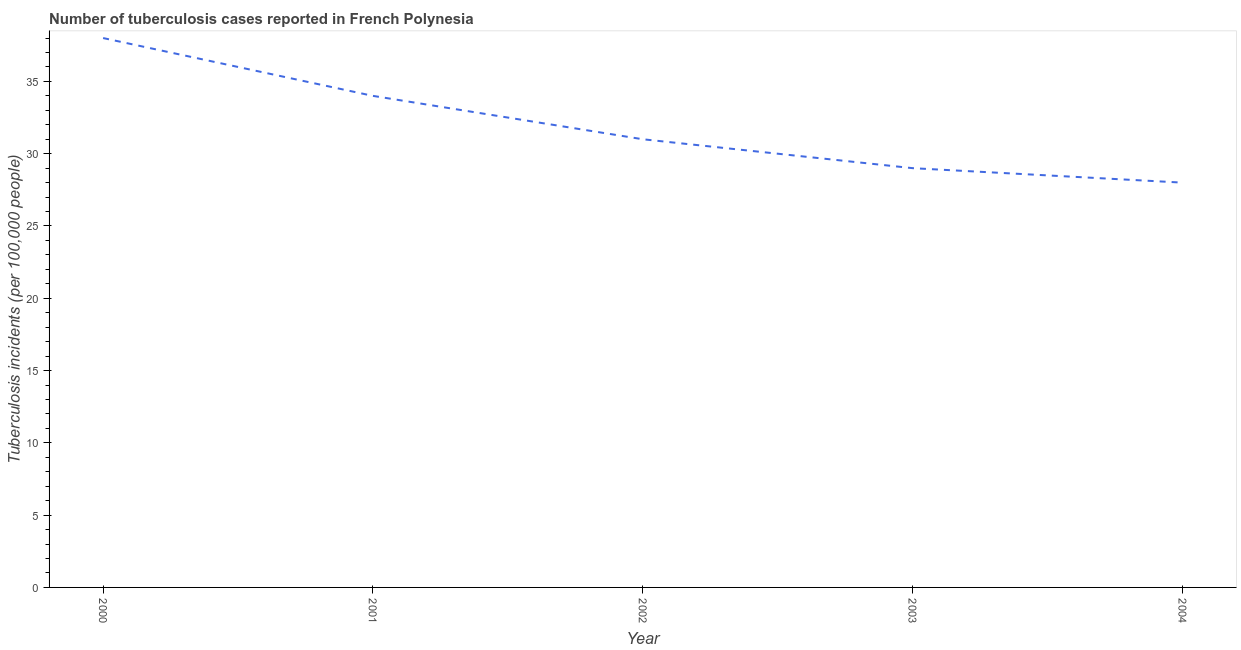What is the number of tuberculosis incidents in 2003?
Offer a very short reply. 29. Across all years, what is the maximum number of tuberculosis incidents?
Your response must be concise. 38. Across all years, what is the minimum number of tuberculosis incidents?
Keep it short and to the point. 28. In which year was the number of tuberculosis incidents maximum?
Your answer should be compact. 2000. In which year was the number of tuberculosis incidents minimum?
Provide a short and direct response. 2004. What is the sum of the number of tuberculosis incidents?
Your answer should be compact. 160. What is the difference between the number of tuberculosis incidents in 2000 and 2004?
Offer a very short reply. 10. What is the median number of tuberculosis incidents?
Give a very brief answer. 31. In how many years, is the number of tuberculosis incidents greater than 31 ?
Give a very brief answer. 2. Do a majority of the years between 2004 and 2003 (inclusive) have number of tuberculosis incidents greater than 1 ?
Provide a succinct answer. No. What is the ratio of the number of tuberculosis incidents in 2001 to that in 2004?
Provide a short and direct response. 1.21. Is the number of tuberculosis incidents in 2000 less than that in 2001?
Ensure brevity in your answer.  No. Is the difference between the number of tuberculosis incidents in 2002 and 2003 greater than the difference between any two years?
Make the answer very short. No. Is the sum of the number of tuberculosis incidents in 2001 and 2002 greater than the maximum number of tuberculosis incidents across all years?
Offer a terse response. Yes. What is the difference between the highest and the lowest number of tuberculosis incidents?
Your response must be concise. 10. In how many years, is the number of tuberculosis incidents greater than the average number of tuberculosis incidents taken over all years?
Keep it short and to the point. 2. How many years are there in the graph?
Make the answer very short. 5. What is the difference between two consecutive major ticks on the Y-axis?
Offer a terse response. 5. Are the values on the major ticks of Y-axis written in scientific E-notation?
Offer a very short reply. No. Does the graph contain any zero values?
Offer a terse response. No. What is the title of the graph?
Make the answer very short. Number of tuberculosis cases reported in French Polynesia. What is the label or title of the Y-axis?
Your answer should be compact. Tuberculosis incidents (per 100,0 people). What is the Tuberculosis incidents (per 100,000 people) in 2001?
Your answer should be compact. 34. What is the Tuberculosis incidents (per 100,000 people) of 2004?
Offer a very short reply. 28. What is the difference between the Tuberculosis incidents (per 100,000 people) in 2000 and 2004?
Offer a terse response. 10. What is the difference between the Tuberculosis incidents (per 100,000 people) in 2001 and 2002?
Your answer should be very brief. 3. What is the difference between the Tuberculosis incidents (per 100,000 people) in 2001 and 2003?
Provide a short and direct response. 5. What is the difference between the Tuberculosis incidents (per 100,000 people) in 2002 and 2003?
Provide a short and direct response. 2. What is the difference between the Tuberculosis incidents (per 100,000 people) in 2002 and 2004?
Provide a short and direct response. 3. What is the ratio of the Tuberculosis incidents (per 100,000 people) in 2000 to that in 2001?
Keep it short and to the point. 1.12. What is the ratio of the Tuberculosis incidents (per 100,000 people) in 2000 to that in 2002?
Keep it short and to the point. 1.23. What is the ratio of the Tuberculosis incidents (per 100,000 people) in 2000 to that in 2003?
Your response must be concise. 1.31. What is the ratio of the Tuberculosis incidents (per 100,000 people) in 2000 to that in 2004?
Your answer should be very brief. 1.36. What is the ratio of the Tuberculosis incidents (per 100,000 people) in 2001 to that in 2002?
Offer a terse response. 1.1. What is the ratio of the Tuberculosis incidents (per 100,000 people) in 2001 to that in 2003?
Keep it short and to the point. 1.17. What is the ratio of the Tuberculosis incidents (per 100,000 people) in 2001 to that in 2004?
Offer a terse response. 1.21. What is the ratio of the Tuberculosis incidents (per 100,000 people) in 2002 to that in 2003?
Make the answer very short. 1.07. What is the ratio of the Tuberculosis incidents (per 100,000 people) in 2002 to that in 2004?
Your response must be concise. 1.11. What is the ratio of the Tuberculosis incidents (per 100,000 people) in 2003 to that in 2004?
Your answer should be very brief. 1.04. 